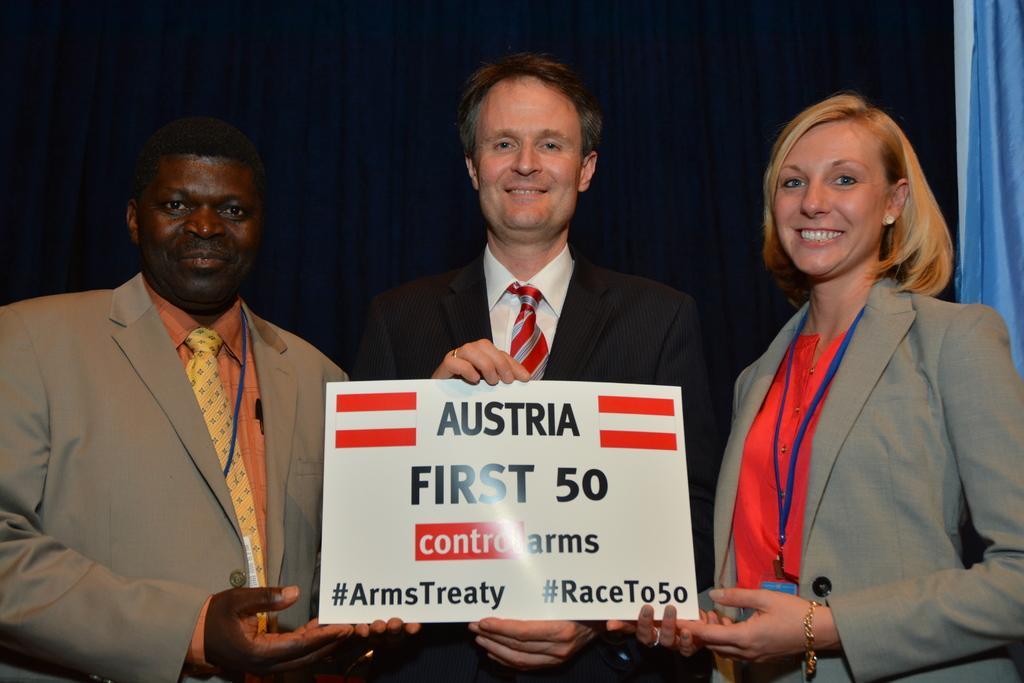Could you give a brief overview of what you see in this image? In the middle of the image three persons are standing, smiling and holding a banner. Behind them we can see some clothes. 